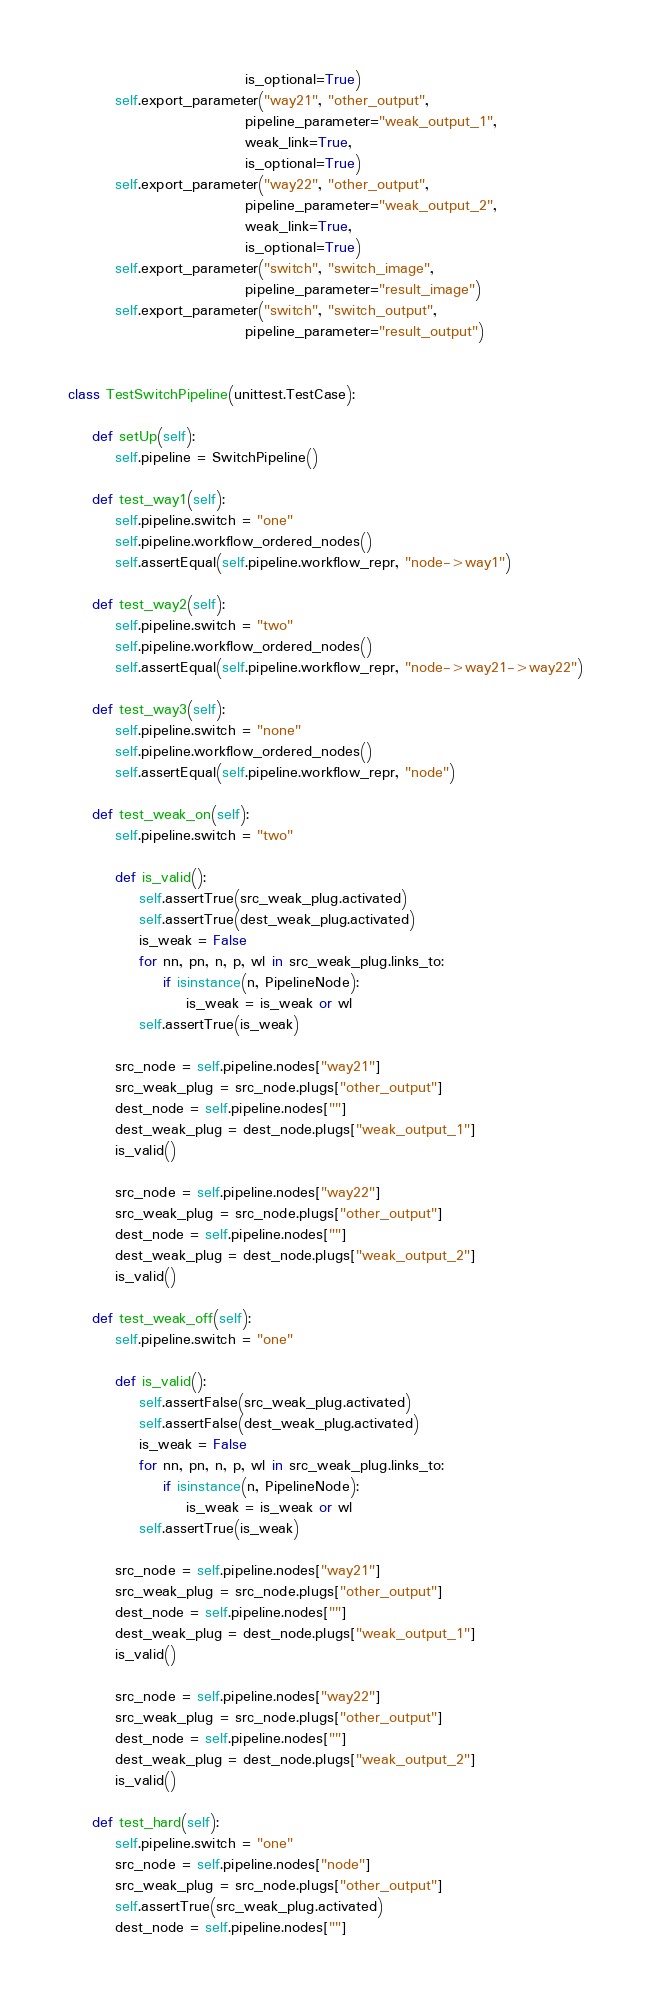<code> <loc_0><loc_0><loc_500><loc_500><_Python_>                              is_optional=True)
        self.export_parameter("way21", "other_output",
                              pipeline_parameter="weak_output_1",
                              weak_link=True,
                              is_optional=True)
        self.export_parameter("way22", "other_output",
                              pipeline_parameter="weak_output_2",
                              weak_link=True,
                              is_optional=True)
        self.export_parameter("switch", "switch_image",
                              pipeline_parameter="result_image")
        self.export_parameter("switch", "switch_output",
                              pipeline_parameter="result_output")


class TestSwitchPipeline(unittest.TestCase):

    def setUp(self):
        self.pipeline = SwitchPipeline()

    def test_way1(self):
        self.pipeline.switch = "one"
        self.pipeline.workflow_ordered_nodes()
        self.assertEqual(self.pipeline.workflow_repr, "node->way1")

    def test_way2(self):
        self.pipeline.switch = "two"
        self.pipeline.workflow_ordered_nodes()
        self.assertEqual(self.pipeline.workflow_repr, "node->way21->way22")

    def test_way3(self):
        self.pipeline.switch = "none"
        self.pipeline.workflow_ordered_nodes()
        self.assertEqual(self.pipeline.workflow_repr, "node")

    def test_weak_on(self):
        self.pipeline.switch = "two"

        def is_valid():
            self.assertTrue(src_weak_plug.activated)
            self.assertTrue(dest_weak_plug.activated)
            is_weak = False
            for nn, pn, n, p, wl in src_weak_plug.links_to:
                if isinstance(n, PipelineNode):
                    is_weak = is_weak or wl
            self.assertTrue(is_weak)

        src_node = self.pipeline.nodes["way21"]
        src_weak_plug = src_node.plugs["other_output"]
        dest_node = self.pipeline.nodes[""]
        dest_weak_plug = dest_node.plugs["weak_output_1"]
        is_valid()

        src_node = self.pipeline.nodes["way22"]
        src_weak_plug = src_node.plugs["other_output"]
        dest_node = self.pipeline.nodes[""]
        dest_weak_plug = dest_node.plugs["weak_output_2"]
        is_valid()

    def test_weak_off(self):
        self.pipeline.switch = "one"

        def is_valid():
            self.assertFalse(src_weak_plug.activated)
            self.assertFalse(dest_weak_plug.activated)
            is_weak = False
            for nn, pn, n, p, wl in src_weak_plug.links_to:
                if isinstance(n, PipelineNode):
                    is_weak = is_weak or wl
            self.assertTrue(is_weak)

        src_node = self.pipeline.nodes["way21"]
        src_weak_plug = src_node.plugs["other_output"]
        dest_node = self.pipeline.nodes[""]
        dest_weak_plug = dest_node.plugs["weak_output_1"]
        is_valid()

        src_node = self.pipeline.nodes["way22"]
        src_weak_plug = src_node.plugs["other_output"]
        dest_node = self.pipeline.nodes[""]
        dest_weak_plug = dest_node.plugs["weak_output_2"]
        is_valid()

    def test_hard(self):
        self.pipeline.switch = "one"
        src_node = self.pipeline.nodes["node"]
        src_weak_plug = src_node.plugs["other_output"]
        self.assertTrue(src_weak_plug.activated)
        dest_node = self.pipeline.nodes[""]</code> 